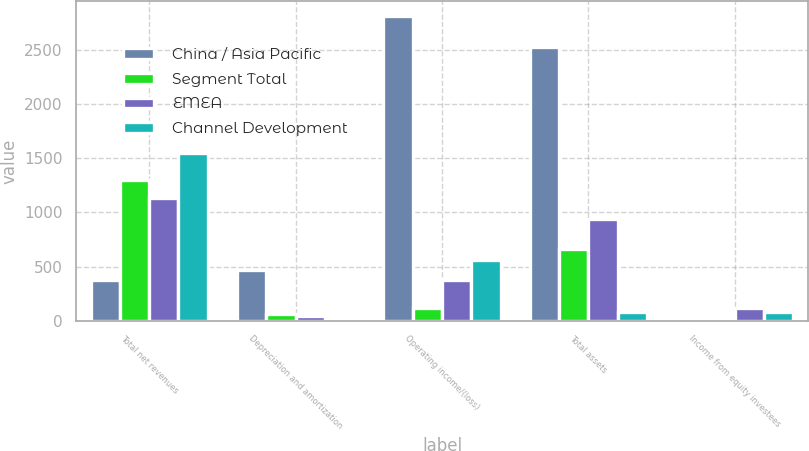Convert chart to OTSL. <chart><loc_0><loc_0><loc_500><loc_500><stacked_bar_chart><ecel><fcel>Total net revenues<fcel>Depreciation and amortization<fcel>Operating income/(loss)<fcel>Total assets<fcel>Income from equity investees<nl><fcel>China / Asia Pacific<fcel>372.5<fcel>469.5<fcel>2809<fcel>2521.4<fcel>2.1<nl><fcel>Segment Total<fcel>1294.8<fcel>59.4<fcel>119.2<fcel>663<fcel>0.3<nl><fcel>EMEA<fcel>1129.6<fcel>46.1<fcel>372.5<fcel>939.8<fcel>122.4<nl><fcel>Channel Development<fcel>1546<fcel>1.8<fcel>557.2<fcel>84.6<fcel>85.2<nl></chart> 